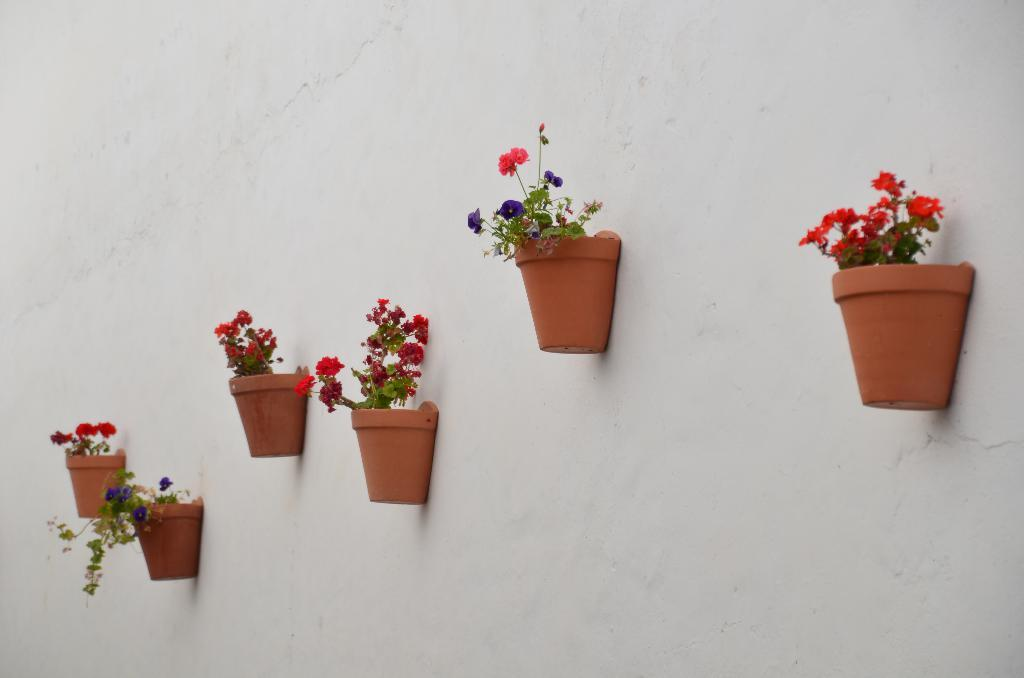How many flower pots are present in the image? There are two flower pots in the image. What is inside the flower pots? The flower pots contain plants. What can be observed on the plants? The plants have flowers. How are the flower pots positioned in the image? The flower pots are attached to the wall. What type of egg is visible in the image? There is no egg present in the image. How is the rice being cooked in the image? There is no rice or cooking activity present in the image. 